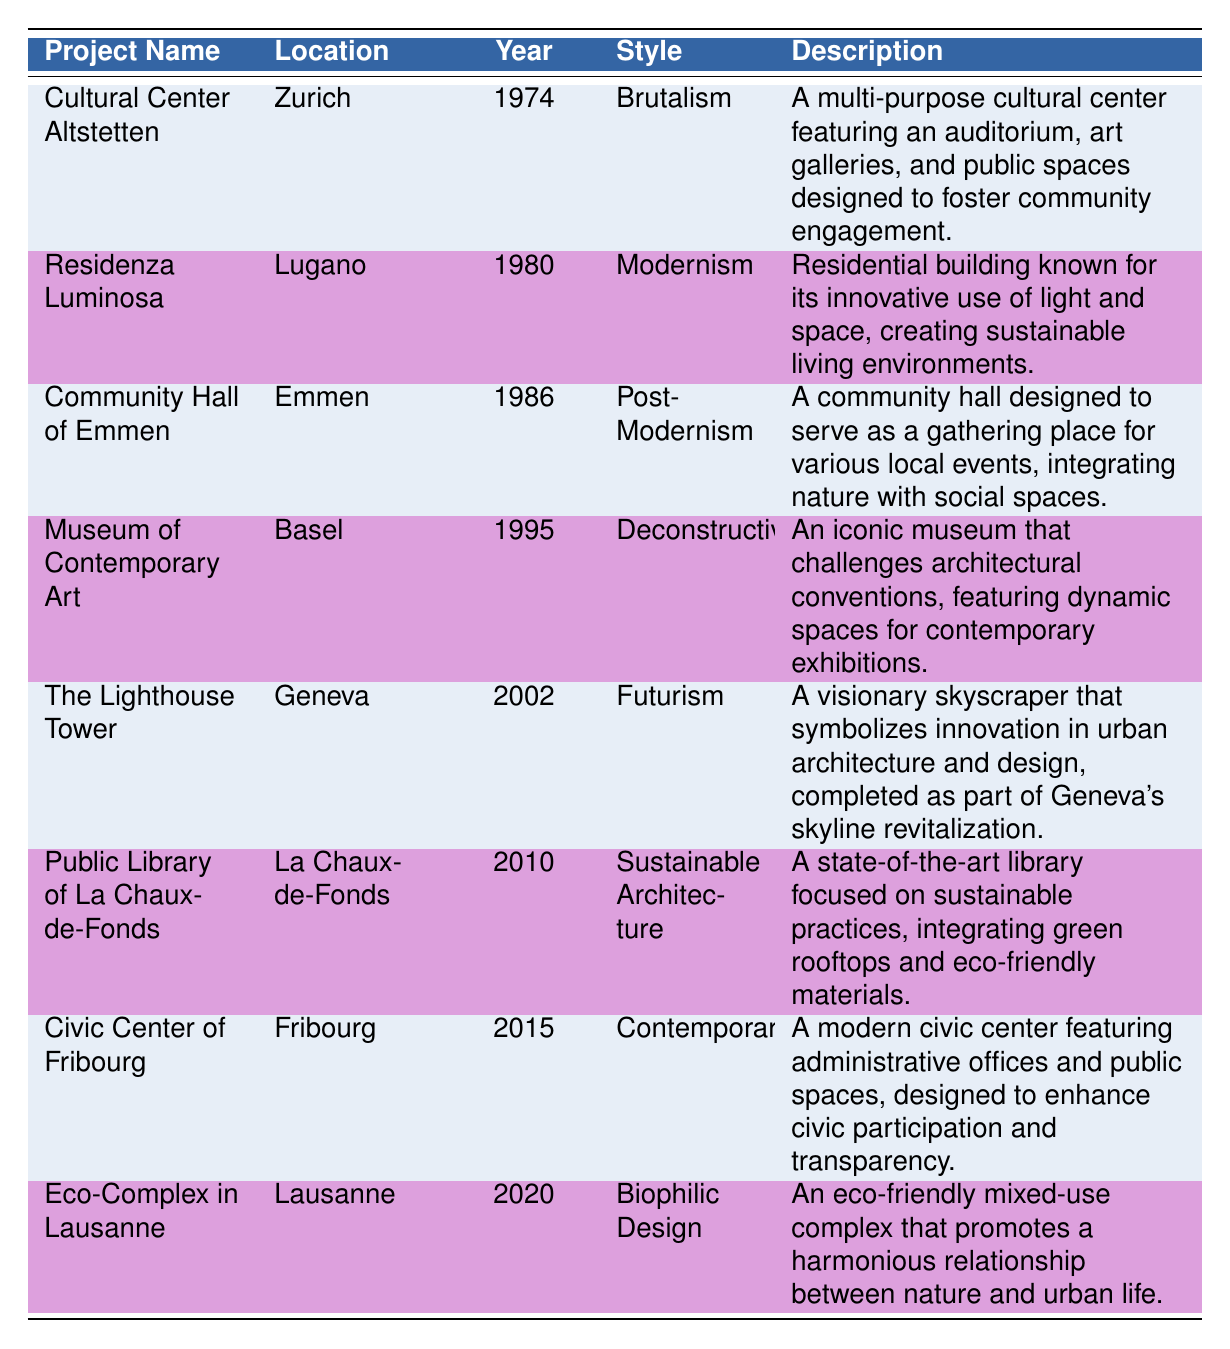What is the location of the Cultural Center Altstetten? The location is given in the table, and for the Cultural Center Altstetten, it is listed as Zurich, Switzerland.
Answer: Zurich, Switzerland Which style is associated with the Museum of Contemporary Art? Referring to the style column in the table, the Museum of Contemporary Art is classified as Deconstructivism.
Answer: Deconstructivism How many projects were completed before the year 2000? To find out, we can count the projects listed with a year completed before 2000. These are Cultural Center Altstetten (1974), Residenza Luminosa (1980), Community Hall of Emmen (1986), Museum of Contemporary Art (1995), and The Lighthouse Tower (2002). Thus, there are 4 projects completed before 2000.
Answer: 4 Is the Public Library of La Chaux-de-Fonds a sustainable architecture project? Based on the description provided in the table, the Public Library of La Chaux-de-Fonds is focused on sustainable practices, which confirms that it is indeed a sustainable architecture project.
Answer: Yes Which project was completed most recently, and what is its style? To determine this, we look for the highest year in the year completed column, which is 2020 for the Eco-Complex in Lausanne. The style associated with this project in the table is Biophilic Design.
Answer: Eco-Complex in Lausanne, Biophilic Design How many projects designed by François Iselin feature community-centric designs? Identifying the projects, we have Cultural Center Altstetten (1974), Community Hall of Emmen (1986), and Civic Center of Fribourg (2015). All these projects emphasize community engagement. Therefore, the total count is 3 projects.
Answer: 3 What is the average year of completion for all the projects listed? To calculate the average, sum the years of completion (1974 + 1980 + 1986 + 1995 + 2002 + 2010 + 2015 + 2020 = 1590) and divide by the number of projects (8). Thus, the average year is 1590/8 = 198.75. Rounding gives us 1989.
Answer: 1989 Is the Lighthouse Tower associated with a particular architectural style? Yes, based on the data from the table, the Lighthouse Tower is classified under the style of Futurism.
Answer: Yes Which two styles are used most frequently in the table, and can you name projects that represent them? Reviewing the styles, both Modernism and Brutalism appear twice. Projects representing Modernism include Residenza Luminosa (1980) and Brutalism includes Cultural Center Altstetten (1974).
Answer: Modernism: Residenza Luminosa, Brutalism: Cultural Center Altstetten 